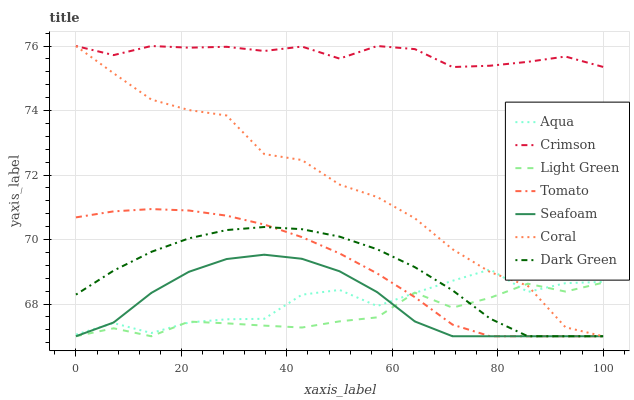Does Light Green have the minimum area under the curve?
Answer yes or no. Yes. Does Crimson have the maximum area under the curve?
Answer yes or no. Yes. Does Coral have the minimum area under the curve?
Answer yes or no. No. Does Coral have the maximum area under the curve?
Answer yes or no. No. Is Tomato the smoothest?
Answer yes or no. Yes. Is Aqua the roughest?
Answer yes or no. Yes. Is Coral the smoothest?
Answer yes or no. No. Is Coral the roughest?
Answer yes or no. No. Does Tomato have the lowest value?
Answer yes or no. Yes. Does Aqua have the lowest value?
Answer yes or no. No. Does Crimson have the highest value?
Answer yes or no. Yes. Does Aqua have the highest value?
Answer yes or no. No. Is Tomato less than Crimson?
Answer yes or no. Yes. Is Crimson greater than Seafoam?
Answer yes or no. Yes. Does Seafoam intersect Dark Green?
Answer yes or no. Yes. Is Seafoam less than Dark Green?
Answer yes or no. No. Is Seafoam greater than Dark Green?
Answer yes or no. No. Does Tomato intersect Crimson?
Answer yes or no. No. 